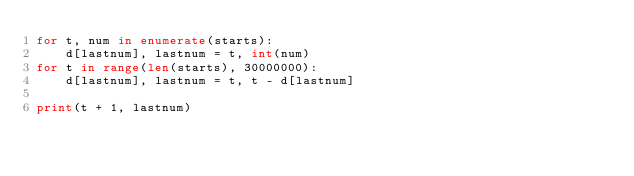Convert code to text. <code><loc_0><loc_0><loc_500><loc_500><_Python_>for t, num in enumerate(starts):
    d[lastnum], lastnum = t, int(num)
for t in range(len(starts), 30000000):
    d[lastnum], lastnum = t, t - d[lastnum]

print(t + 1, lastnum)
</code> 